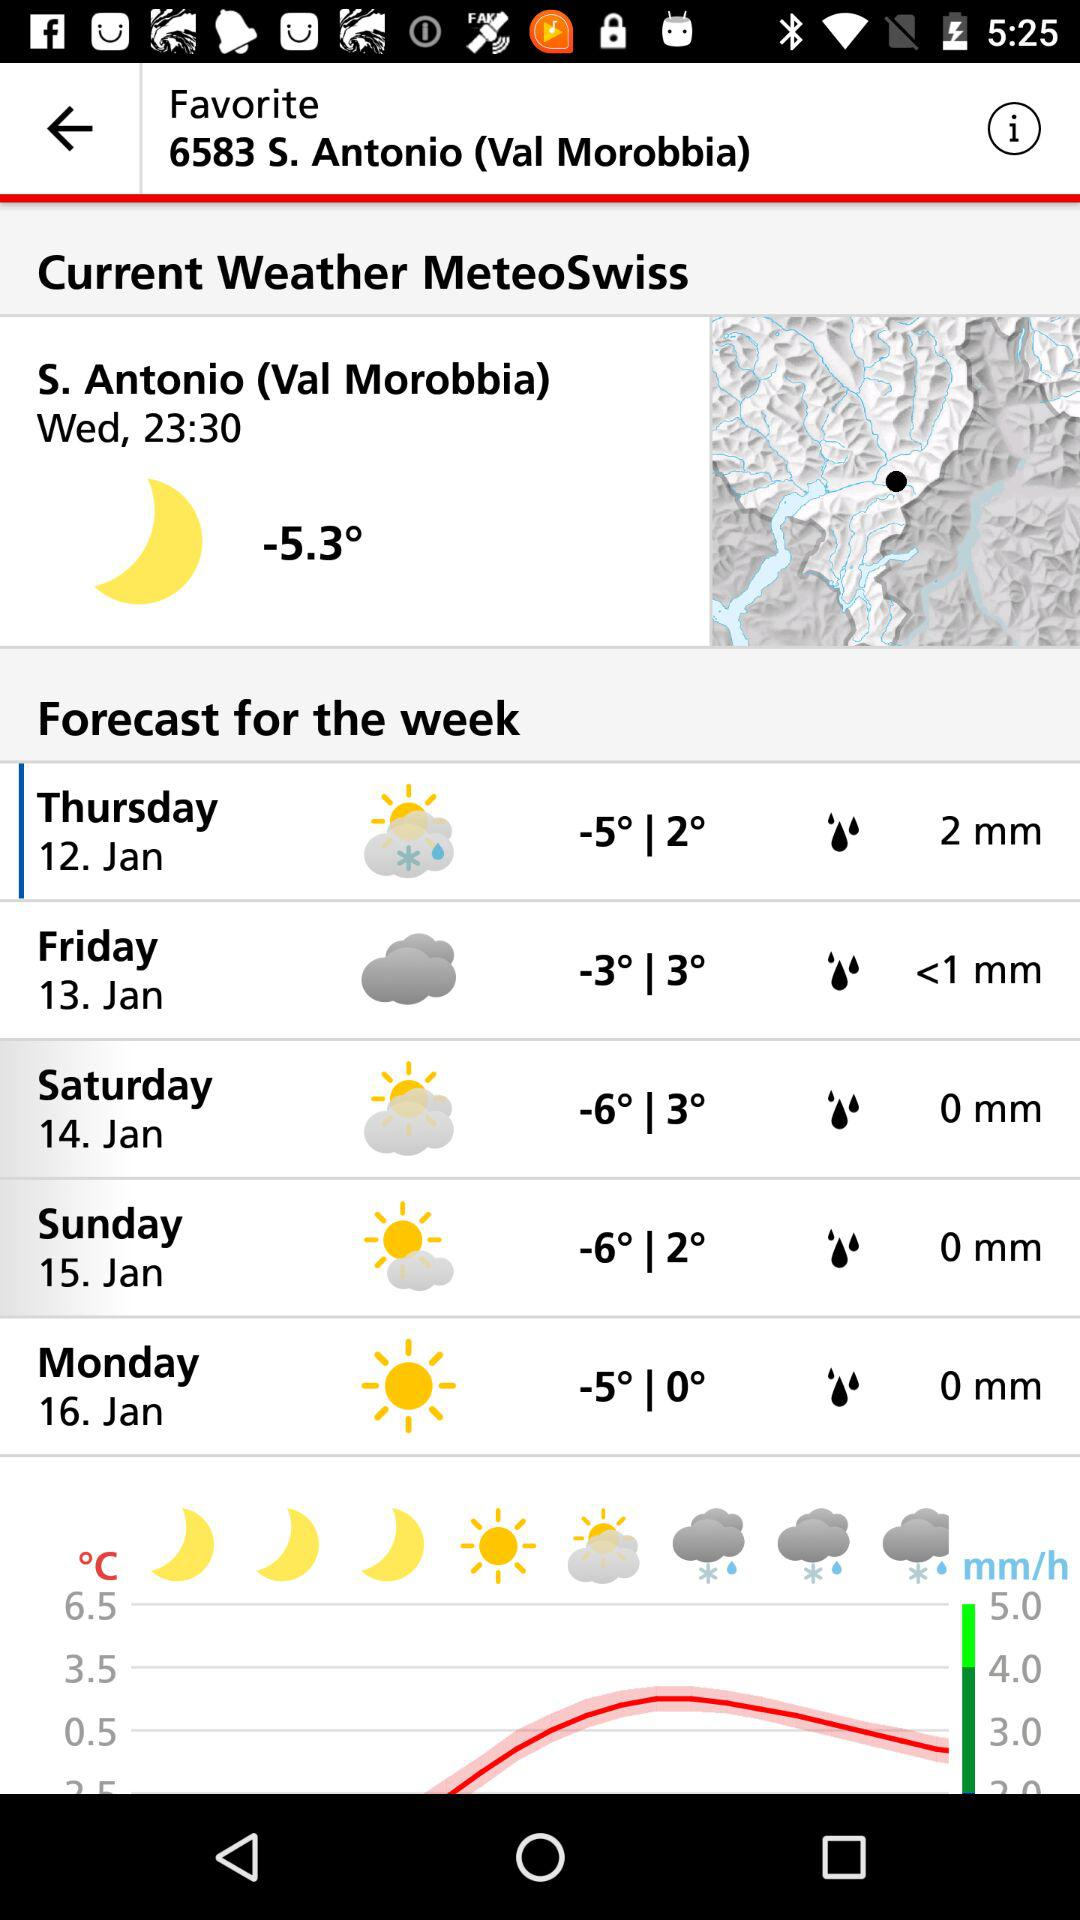What is the current temperature reading at S. Antonio (Val Morobbia)? The current temperature is -5.3 °. 